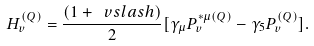Convert formula to latex. <formula><loc_0><loc_0><loc_500><loc_500>H _ { v } ^ { ( Q ) } = \frac { ( 1 + \ v s l a s h ) } { 2 } [ \gamma _ { \mu } P _ { v } ^ { * \mu ( Q ) } - \gamma _ { 5 } P _ { v } ^ { ( Q ) } ] .</formula> 